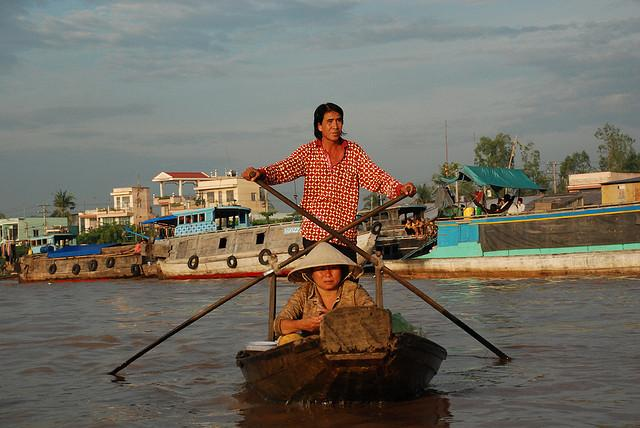The person in the front of the boat is wearing a hat from which continent? Please explain your reasoning. asia. The hat is pointed. 